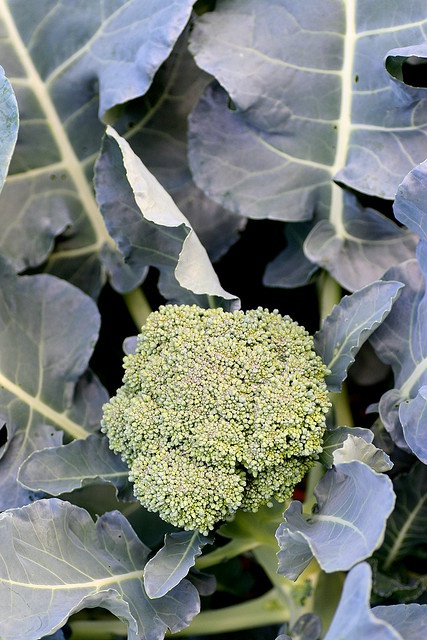Describe the objects in this image and their specific colors. I can see a broccoli in ivory, khaki, olive, beige, and darkgray tones in this image. 